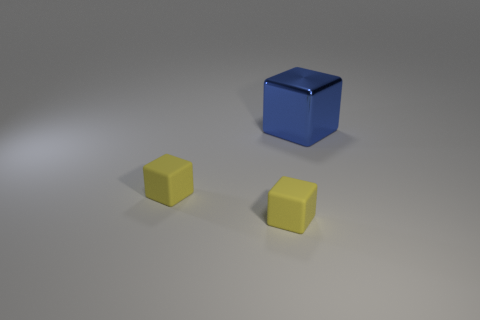Subtract all large blue metal blocks. How many blocks are left? 2 Subtract all green spheres. How many yellow blocks are left? 2 Add 3 big blue shiny things. How many objects exist? 6 Subtract all blue blocks. How many blocks are left? 2 Subtract all red cubes. Subtract all red spheres. How many cubes are left? 3 Subtract all big things. Subtract all large metal cubes. How many objects are left? 1 Add 2 small yellow blocks. How many small yellow blocks are left? 4 Add 1 blue shiny blocks. How many blue shiny blocks exist? 2 Subtract 0 purple spheres. How many objects are left? 3 